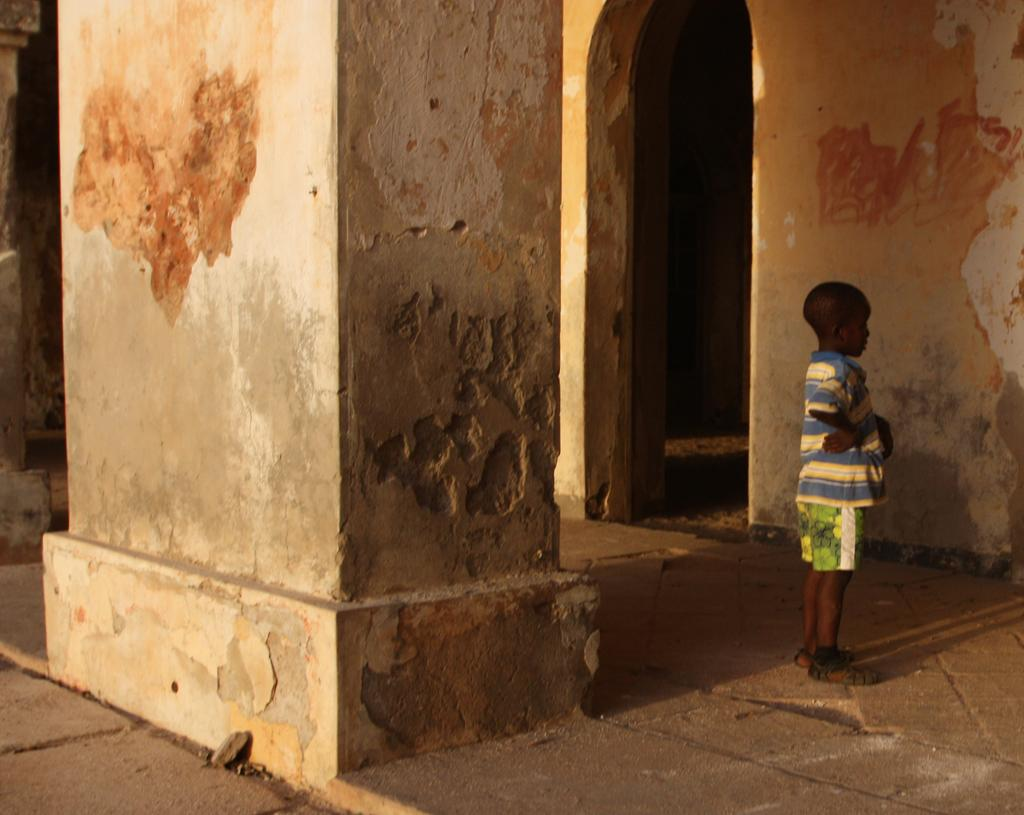Who is present in the image? There is a boy in the image. What structure is visible in the image? There is a building in the image. What architectural features can be seen on the building? The building has pillars and an arch. What type of toy is the boy playing with in the image? There is no toy visible in the image; the boy is not shown playing with anything. 